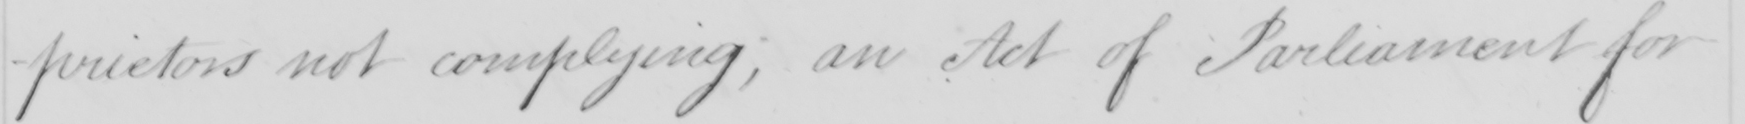Please transcribe the handwritten text in this image. -prietors not complying; an Act of Parliament for 